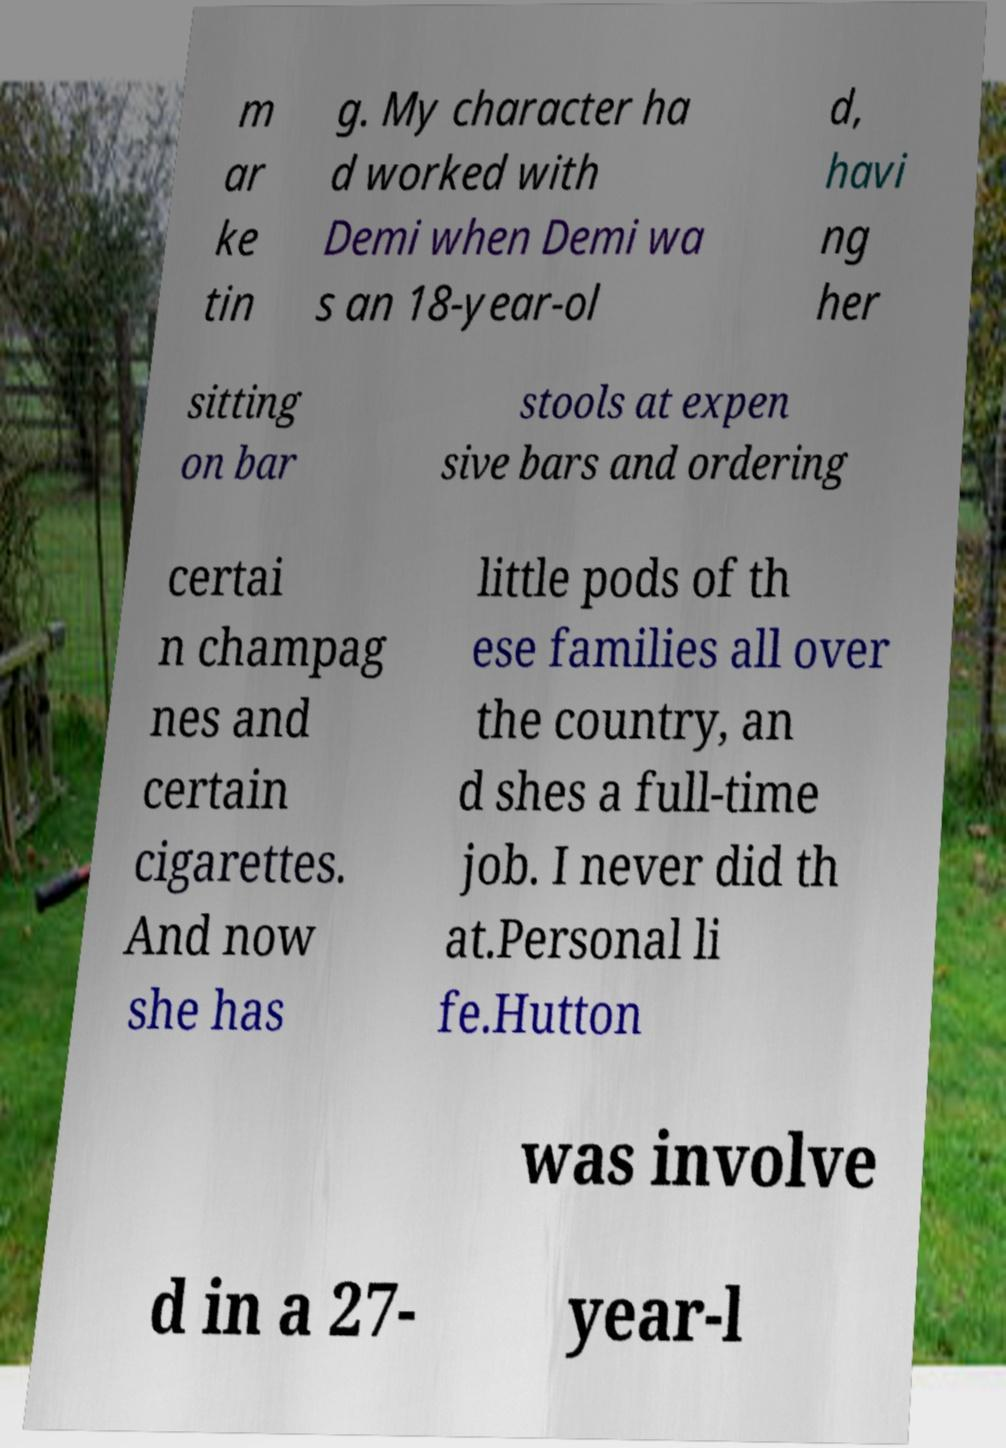Can you read and provide the text displayed in the image?This photo seems to have some interesting text. Can you extract and type it out for me? m ar ke tin g. My character ha d worked with Demi when Demi wa s an 18-year-ol d, havi ng her sitting on bar stools at expen sive bars and ordering certai n champag nes and certain cigarettes. And now she has little pods of th ese families all over the country, an d shes a full-time job. I never did th at.Personal li fe.Hutton was involve d in a 27- year-l 